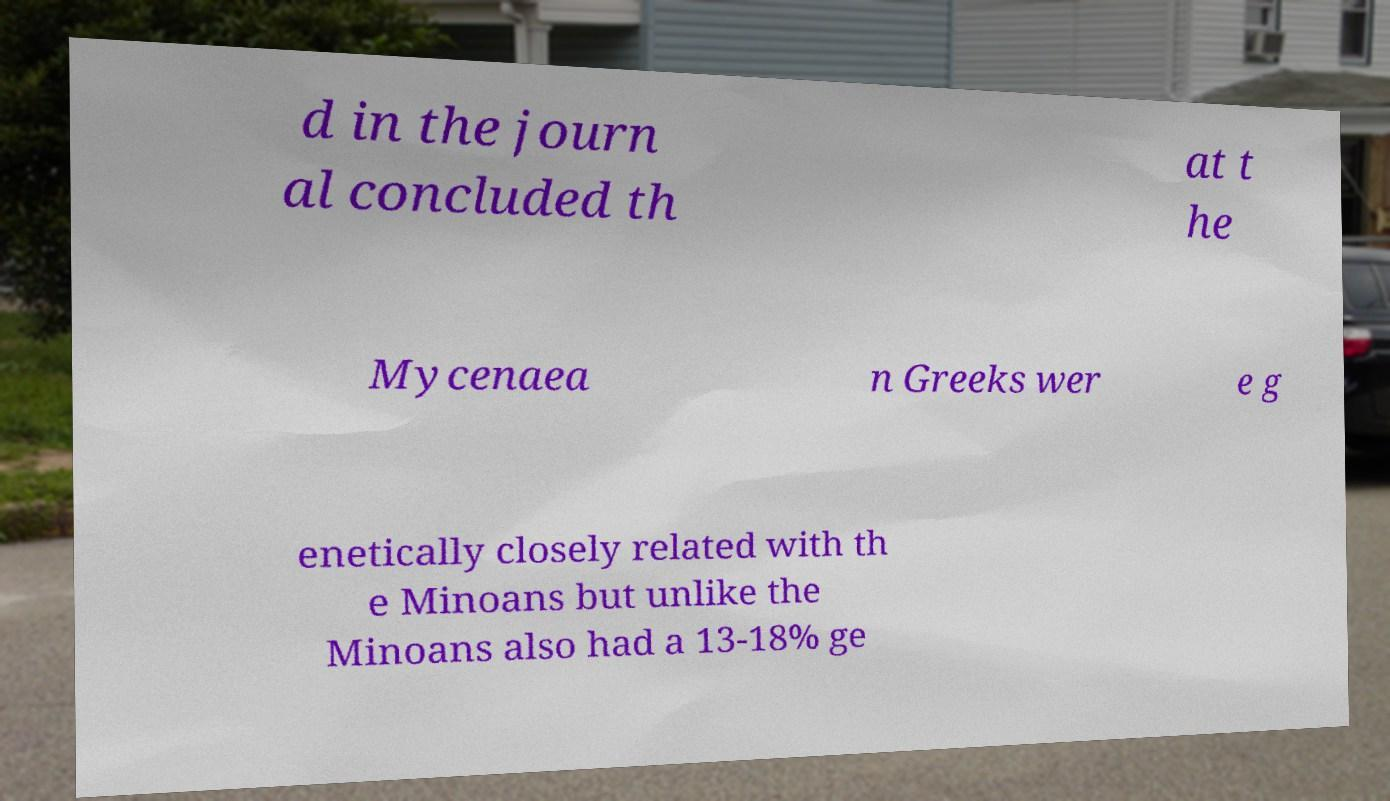What messages or text are displayed in this image? I need them in a readable, typed format. d in the journ al concluded th at t he Mycenaea n Greeks wer e g enetically closely related with th e Minoans but unlike the Minoans also had a 13-18% ge 